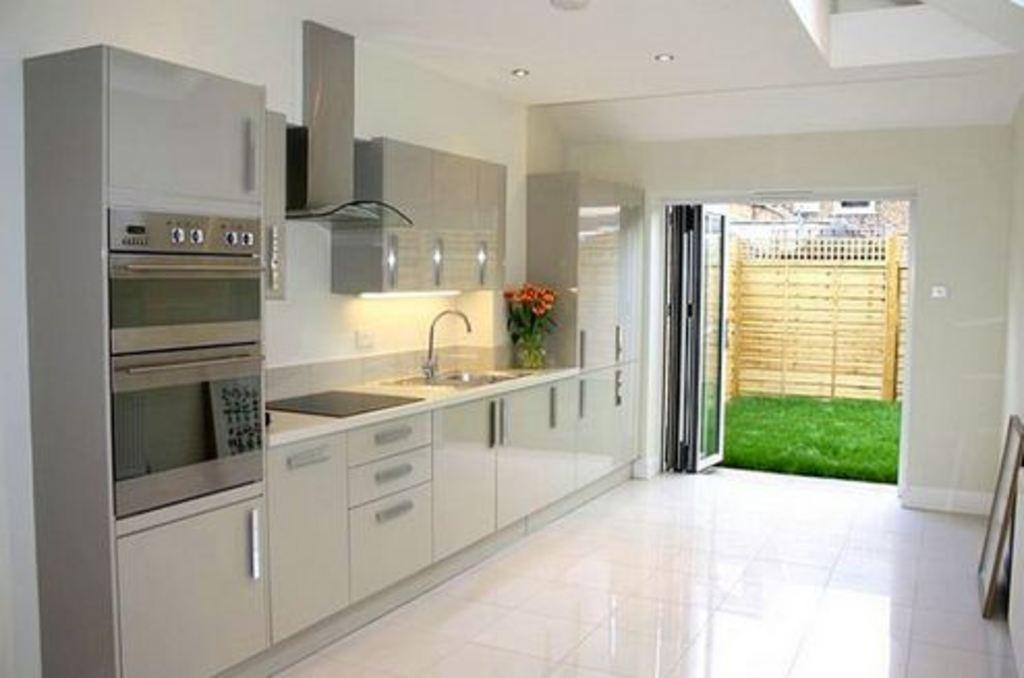How would you summarize this image in a sentence or two? In this image, I can see the cupboards, micro oven, chimney, which are attached to the wall. This picture was taken in the kitchen room. On the right side of the image, I can see a photo frame, which is placed on the floor. In the background, I can see a glass door, grass and a wooden fence. I can see a flower vase with the flower and a sink with a tap on the kitchen cabinet. 